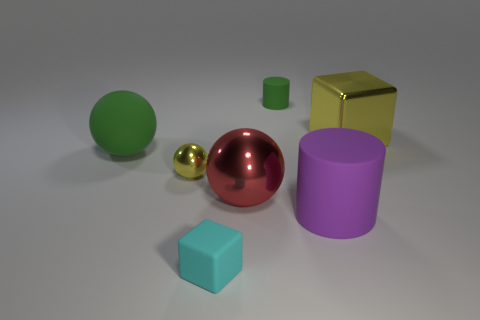Add 2 purple cylinders. How many objects exist? 9 Subtract all blocks. How many objects are left? 5 Subtract 1 yellow balls. How many objects are left? 6 Subtract all small cyan metallic cylinders. Subtract all small yellow metallic spheres. How many objects are left? 6 Add 7 purple rubber objects. How many purple rubber objects are left? 8 Add 2 tiny matte blocks. How many tiny matte blocks exist? 3 